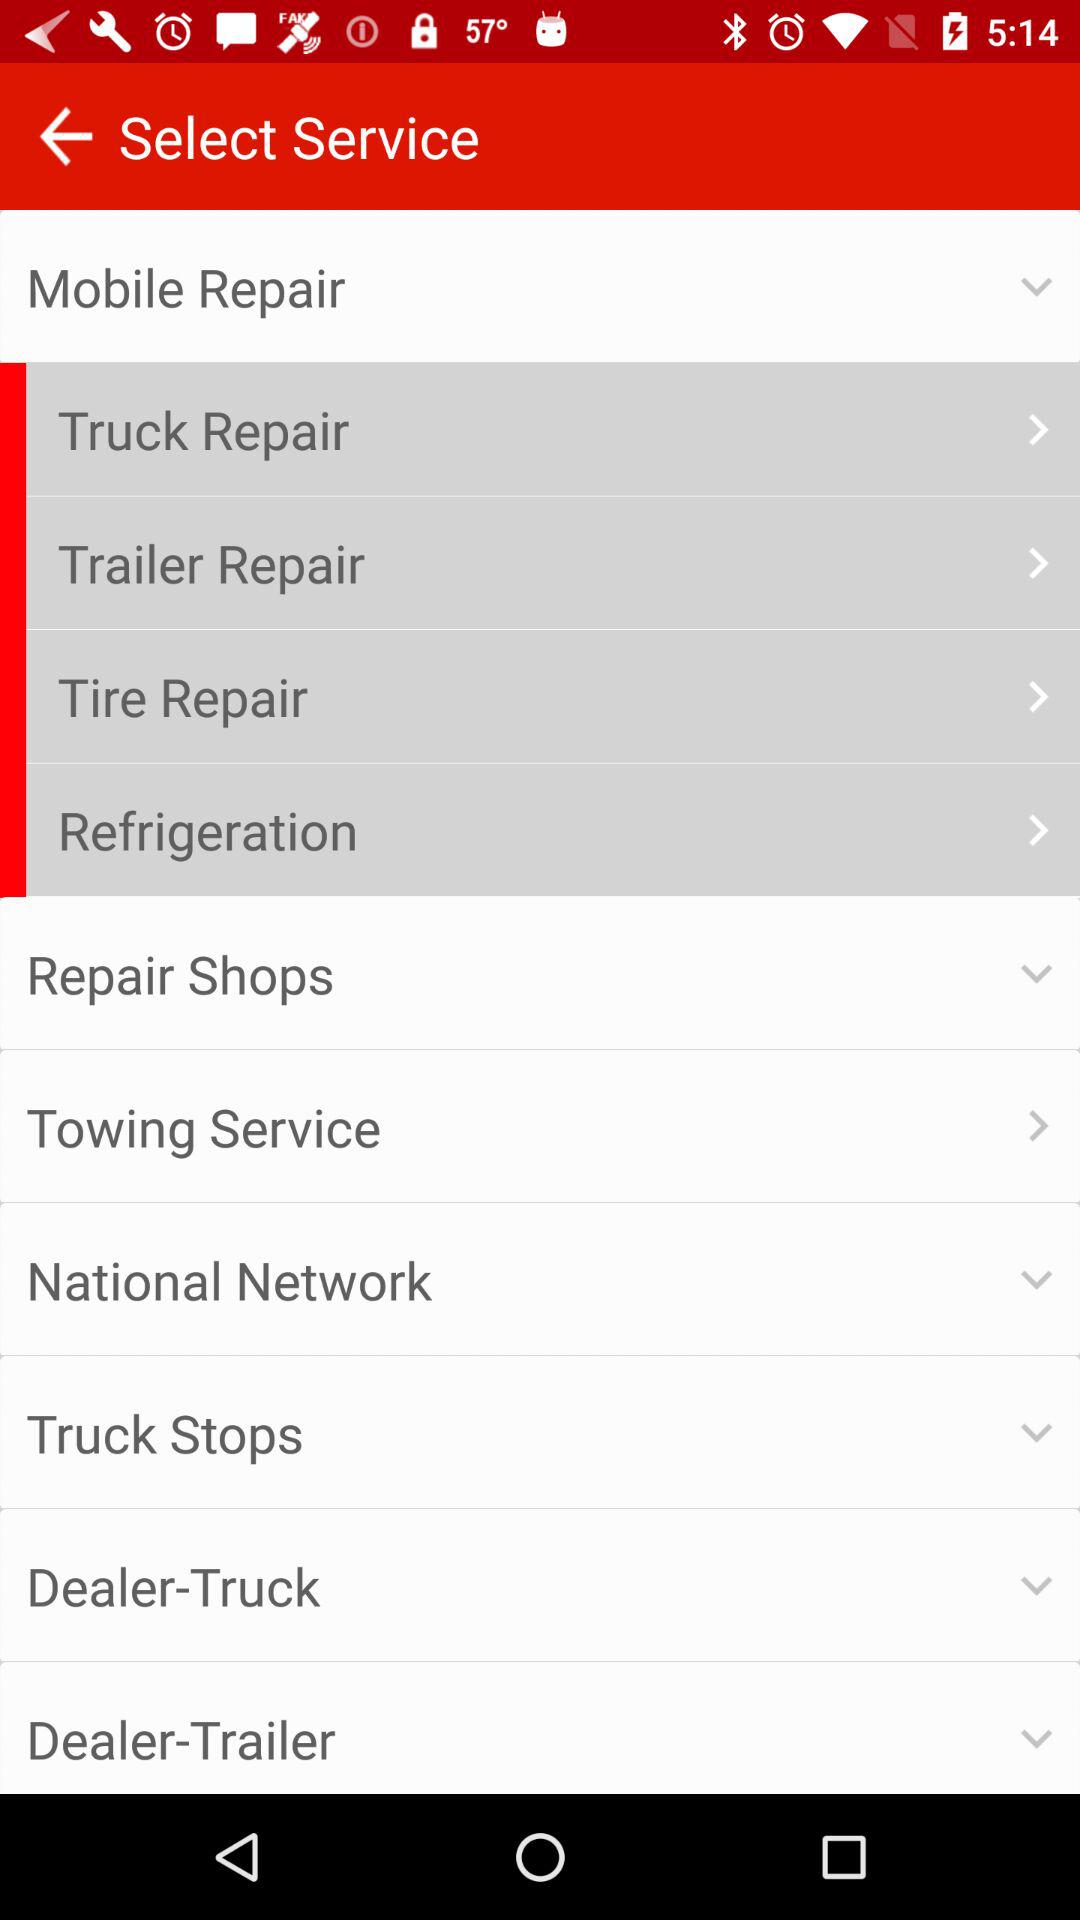Where are the nearest truck stops?
When the provided information is insufficient, respond with <no answer>. <no answer> 